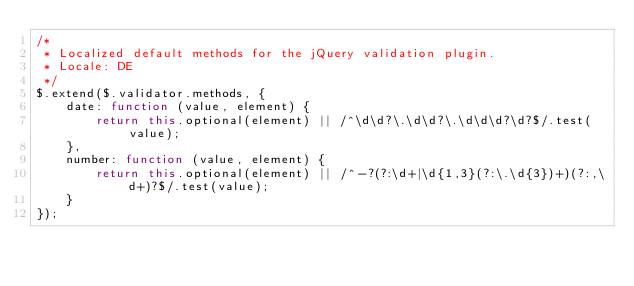Convert code to text. <code><loc_0><loc_0><loc_500><loc_500><_JavaScript_>/*
 * Localized default methods for the jQuery validation plugin.
 * Locale: DE
 */
$.extend($.validator.methods, {
    date: function (value, element) {
        return this.optional(element) || /^\d\d?\.\d\d?\.\d\d\d?\d?$/.test(value);
    },
    number: function (value, element) {
        return this.optional(element) || /^-?(?:\d+|\d{1,3}(?:\.\d{3})+)(?:,\d+)?$/.test(value);
    }
});
</code> 